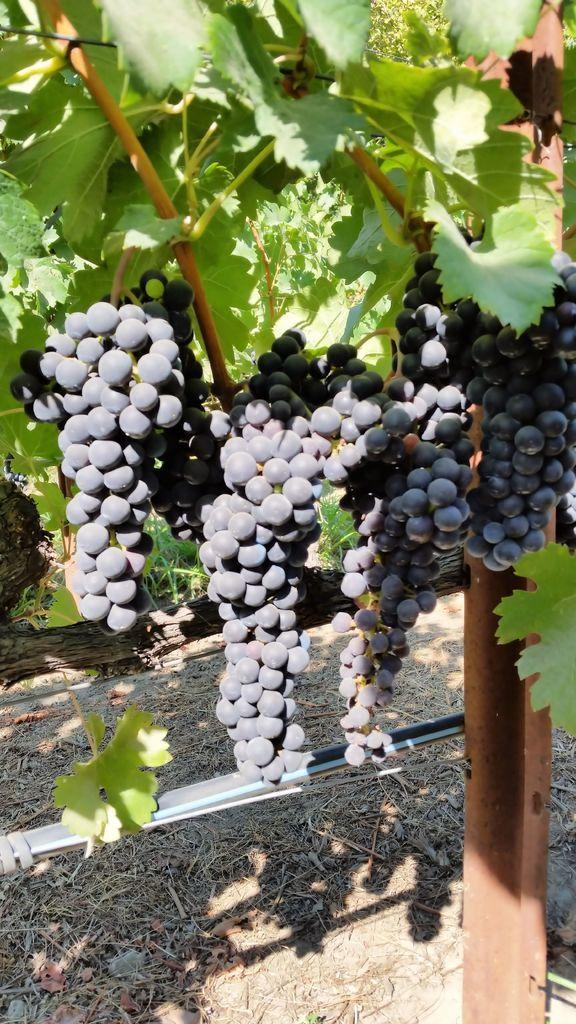What type of food can be seen in the image? There are fruits in the image. What color are the fruits in the image? The fruits are black in color. What can be seen in the background of the image? There are leaves in the background of the image. What color are the leaves in the image? The leaves are green in color. What type of creature is holding the caption in the image? There is no creature or caption present in the image. 